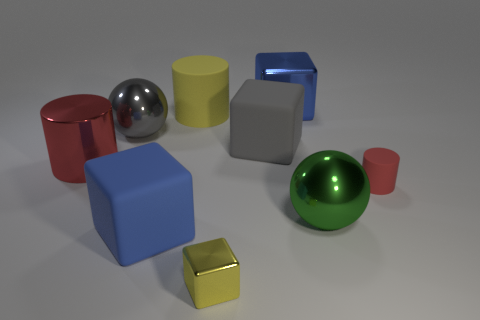Subtract all tiny metallic blocks. How many blocks are left? 3 Subtract all gray blocks. How many blocks are left? 3 Add 1 tiny things. How many objects exist? 10 Subtract all cubes. How many objects are left? 5 Subtract all blue metal objects. Subtract all yellow things. How many objects are left? 6 Add 3 big blue metallic objects. How many big blue metallic objects are left? 4 Add 6 large yellow spheres. How many large yellow spheres exist? 6 Subtract 0 yellow spheres. How many objects are left? 9 Subtract 2 cylinders. How many cylinders are left? 1 Subtract all purple cylinders. Subtract all green balls. How many cylinders are left? 3 